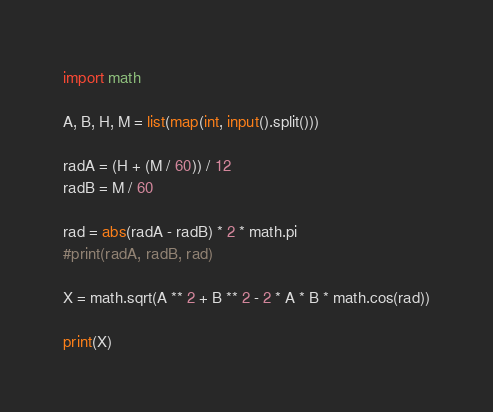Convert code to text. <code><loc_0><loc_0><loc_500><loc_500><_Python_>import math

A, B, H, M = list(map(int, input().split()))

radA = (H + (M / 60)) / 12
radB = M / 60

rad = abs(radA - radB) * 2 * math.pi
#print(radA, radB, rad)

X = math.sqrt(A ** 2 + B ** 2 - 2 * A * B * math.cos(rad))

print(X)</code> 